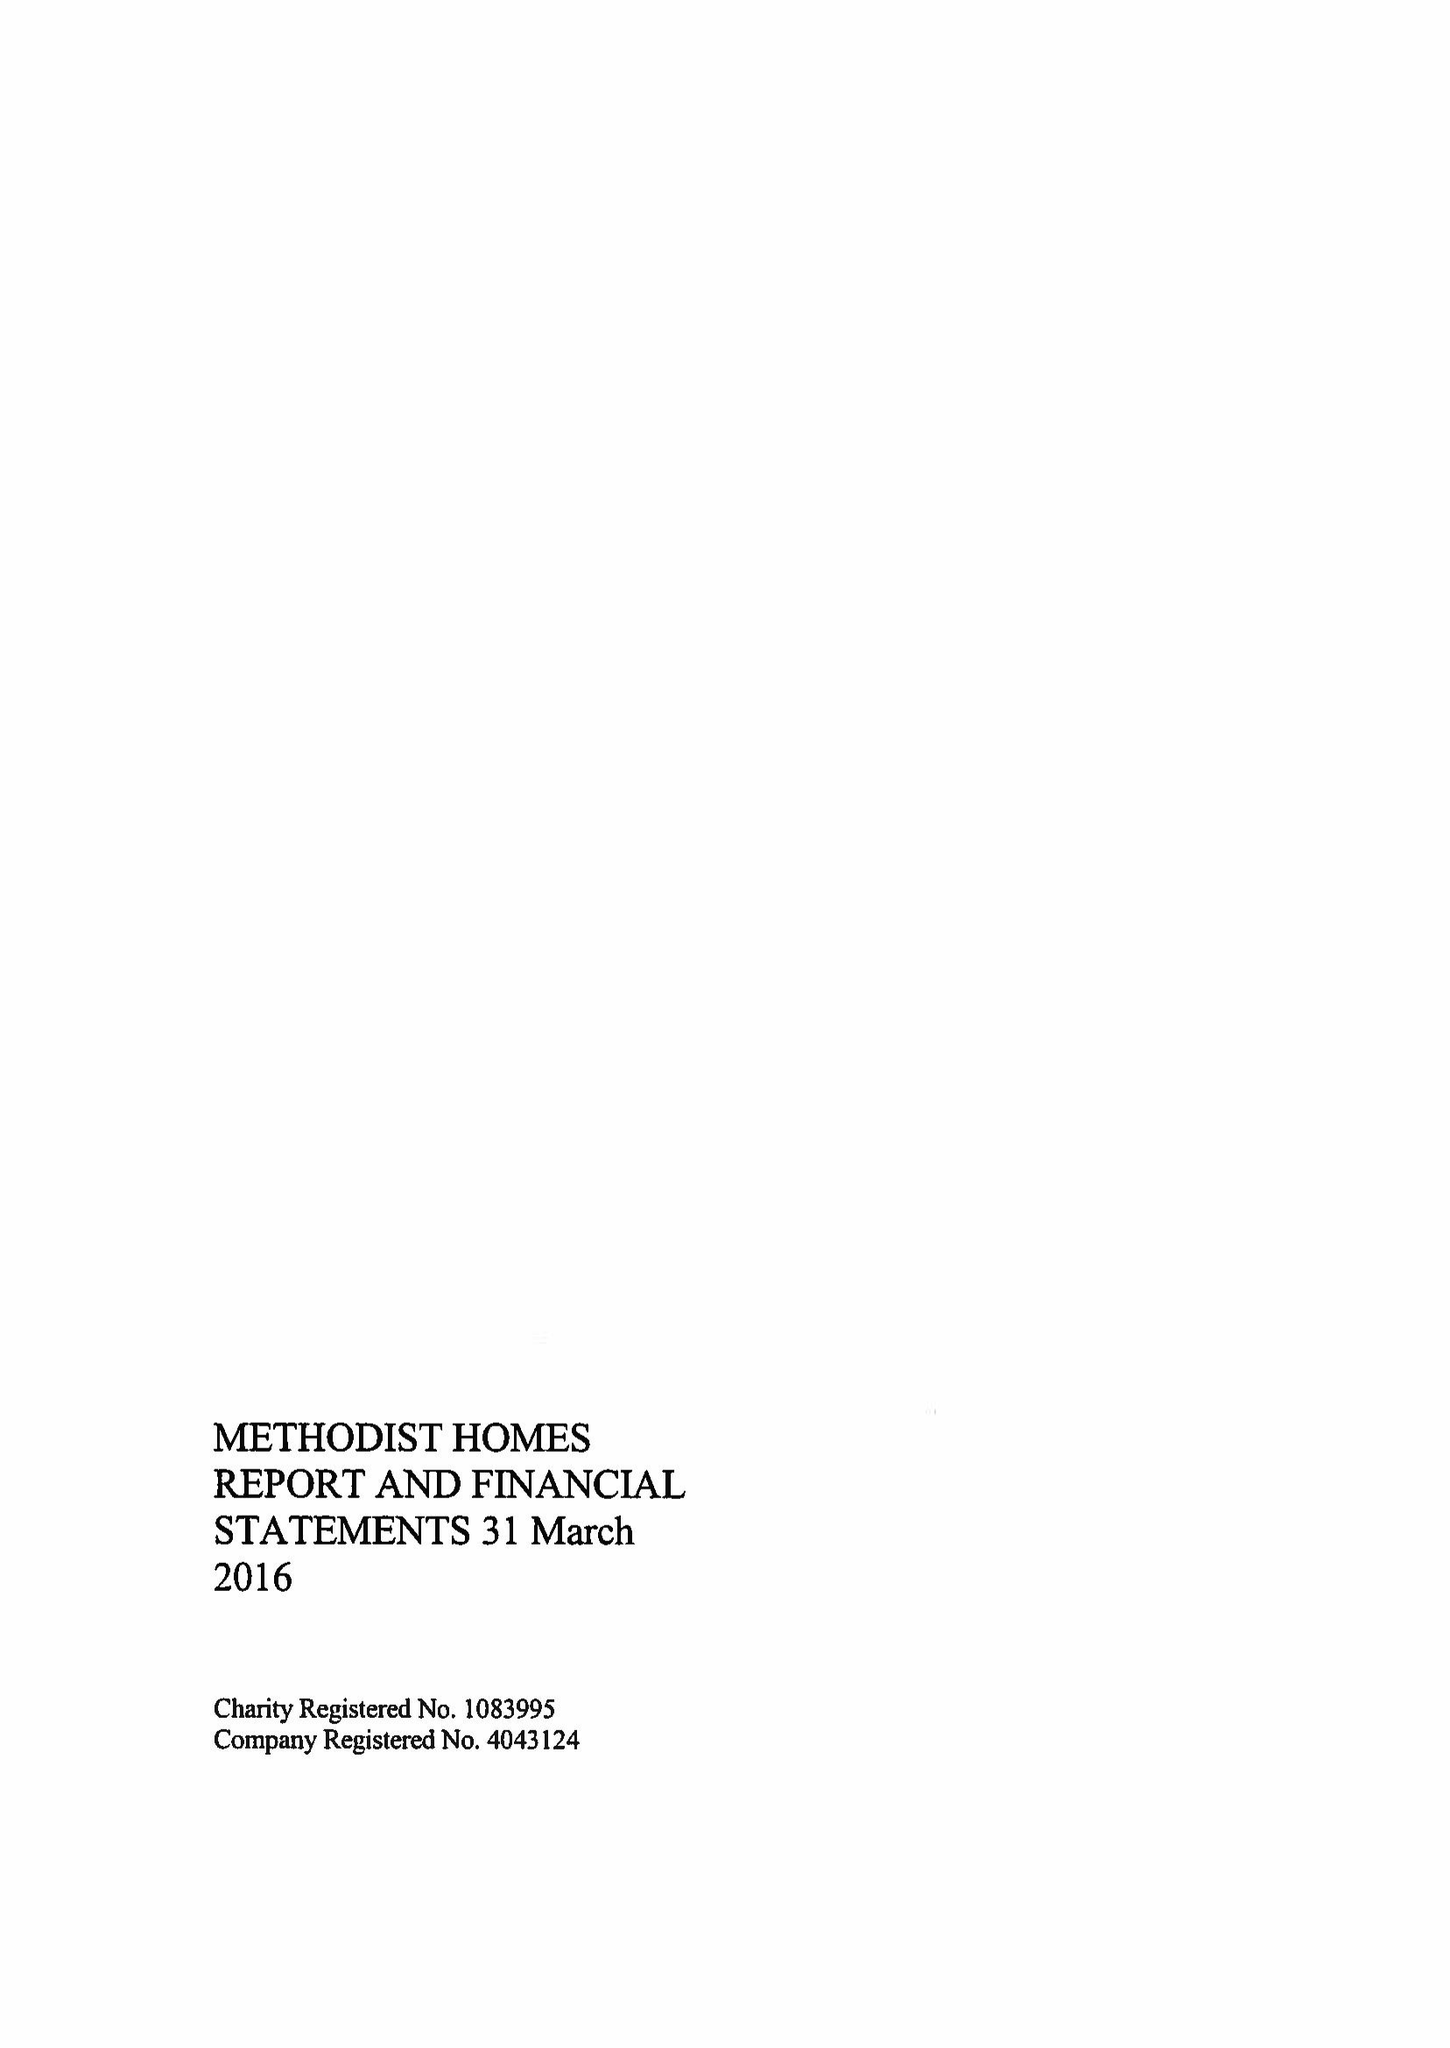What is the value for the spending_annually_in_british_pounds?
Answer the question using a single word or phrase. 184141000.00 